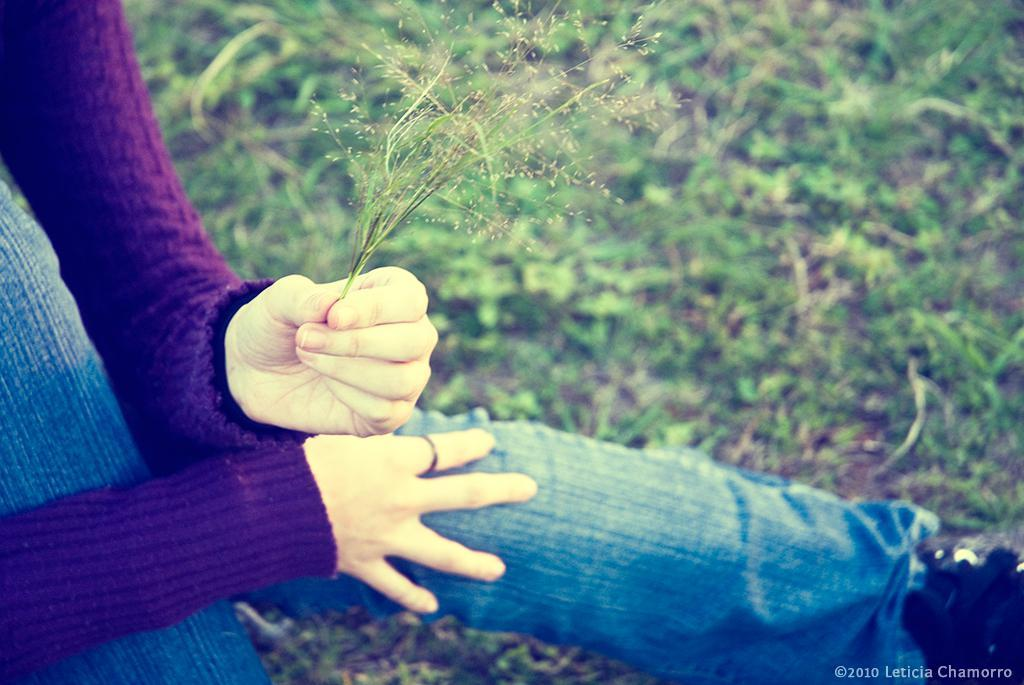Who or what is present in the image? There is a person in the image. What is the person holding? The person is holding grass. What can be seen in the background of the image? There is a grassland in the background of the image. Where is the text located in the image? The text is on the bottom right of the image. How many zebras are visible in the image? There are no zebras present in the image. What type of ring is the person wearing in the image? There is no ring visible on the person in the image. 